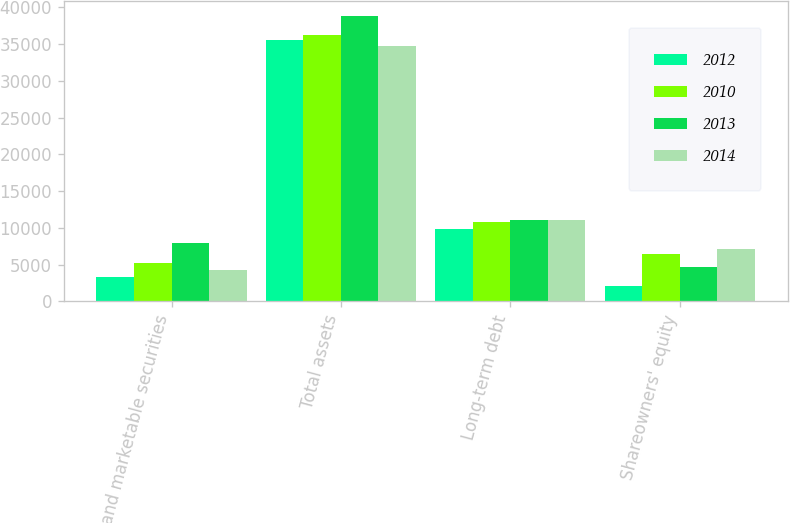Convert chart to OTSL. <chart><loc_0><loc_0><loc_500><loc_500><stacked_bar_chart><ecel><fcel>Cash and marketable securities<fcel>Total assets<fcel>Long-term debt<fcel>Shareowners' equity<nl><fcel>2012<fcel>3283<fcel>35471<fcel>9864<fcel>2158<nl><fcel>2010<fcel>5245<fcel>36212<fcel>10824<fcel>6488<nl><fcel>2013<fcel>7924<fcel>38863<fcel>11089<fcel>4733<nl><fcel>2014<fcel>4275<fcel>34701<fcel>11095<fcel>7108<nl></chart> 